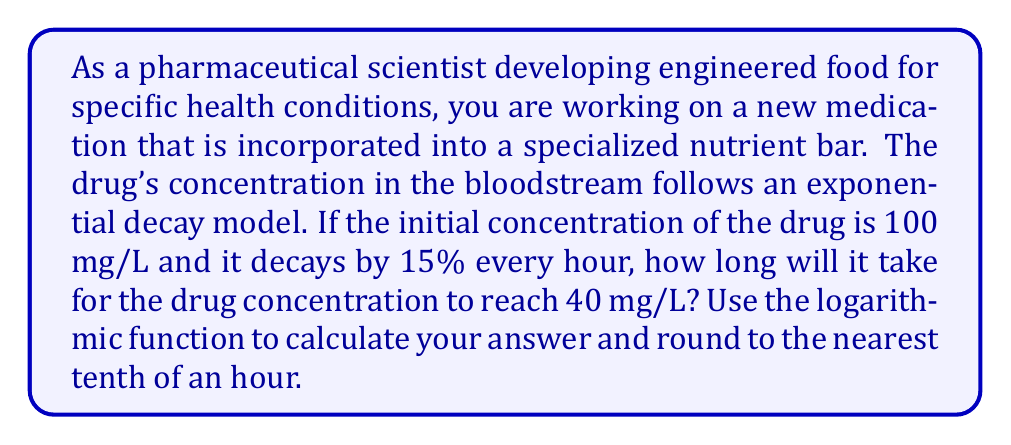Teach me how to tackle this problem. To solve this problem, we'll use the exponential decay formula and then apply logarithms to isolate the time variable.

1) The exponential decay formula is:
   $$C(t) = C_0 \cdot (1-r)^t$$
   where $C(t)$ is the concentration at time $t$, $C_0$ is the initial concentration, and $r$ is the decay rate per unit time.

2) Given:
   $C_0 = 100$ mg/L
   $r = 0.15$ (15% decay per hour)
   $C(t) = 40$ mg/L (target concentration)

3) Substituting these values into the formula:
   $$40 = 100 \cdot (1-0.15)^t$$

4) Simplify:
   $$40 = 100 \cdot (0.85)^t$$

5) Divide both sides by 100:
   $$0.4 = (0.85)^t$$

6) To isolate $t$, we need to take the logarithm of both sides. We can use any base, but natural log (ln) is often convenient:
   $$\ln(0.4) = \ln((0.85)^t)$$

7) Using the logarithm property $\ln(a^b) = b\ln(a)$:
   $$\ln(0.4) = t \cdot \ln(0.85)$$

8) Solve for $t$:
   $$t = \frac{\ln(0.4)}{\ln(0.85)}$$

9) Calculate using a scientific calculator:
   $$t \approx 5.7824$$ hours

10) Rounding to the nearest tenth:
    $t \approx 5.8$ hours
Answer: It will take approximately 5.8 hours for the drug concentration to reach 40 mg/L. 